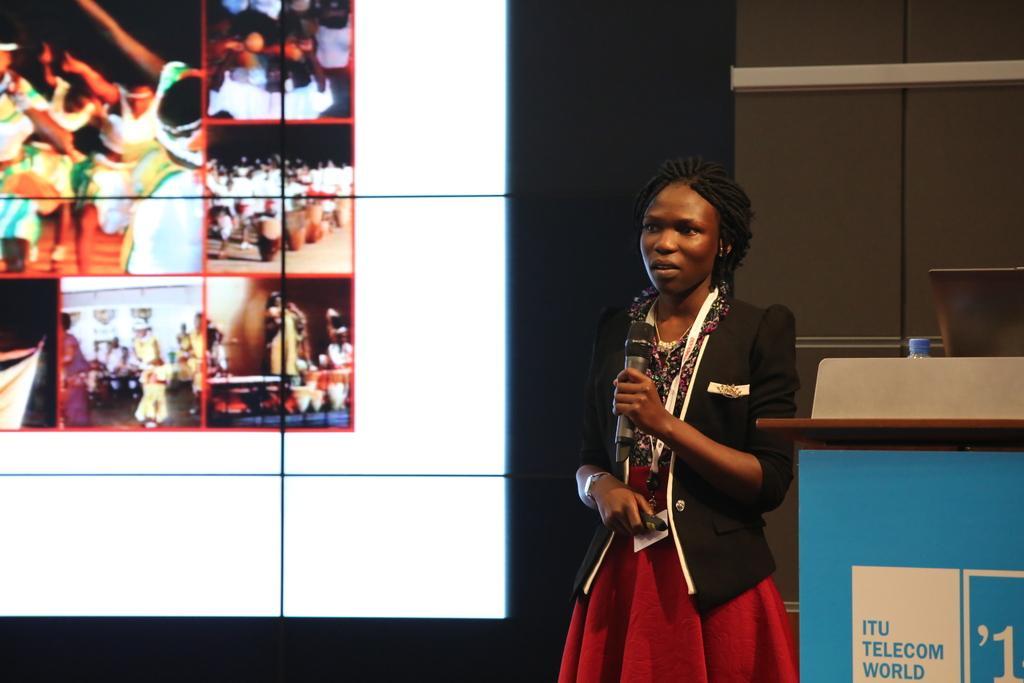Describe this image in one or two sentences. In the background we can see the screen. In this picture we can see a woman is standing holding a microphone and an object. On the right side of the picture we can see a podium, bottle cap is visible and we can see an object. 